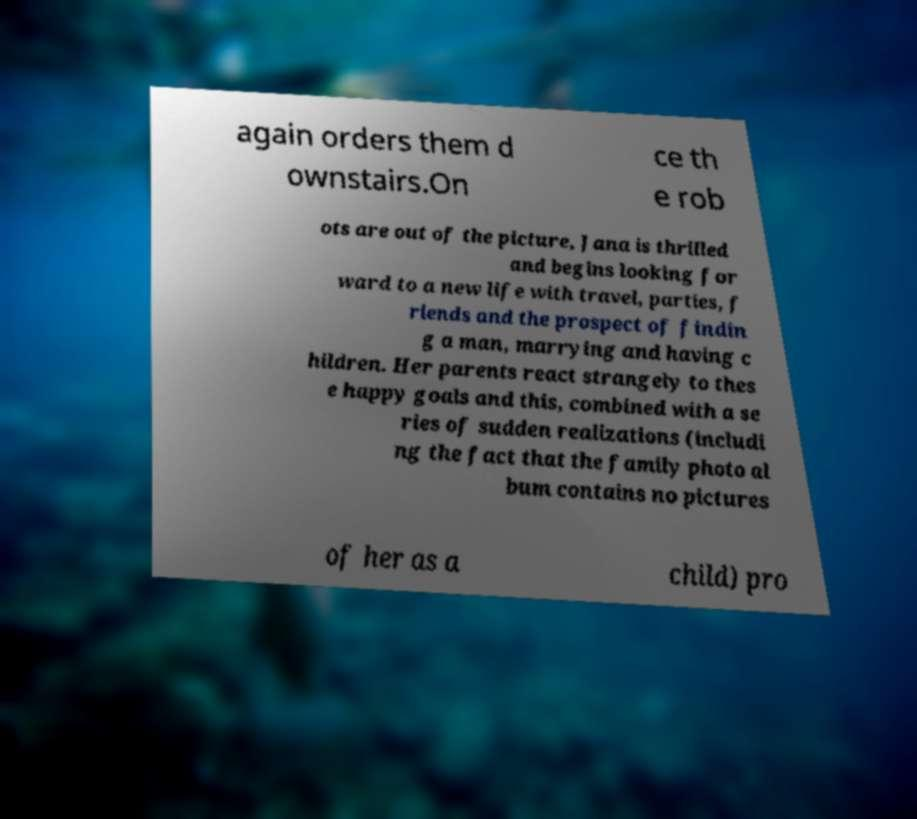There's text embedded in this image that I need extracted. Can you transcribe it verbatim? again orders them d ownstairs.On ce th e rob ots are out of the picture, Jana is thrilled and begins looking for ward to a new life with travel, parties, f riends and the prospect of findin g a man, marrying and having c hildren. Her parents react strangely to thes e happy goals and this, combined with a se ries of sudden realizations (includi ng the fact that the family photo al bum contains no pictures of her as a child) pro 